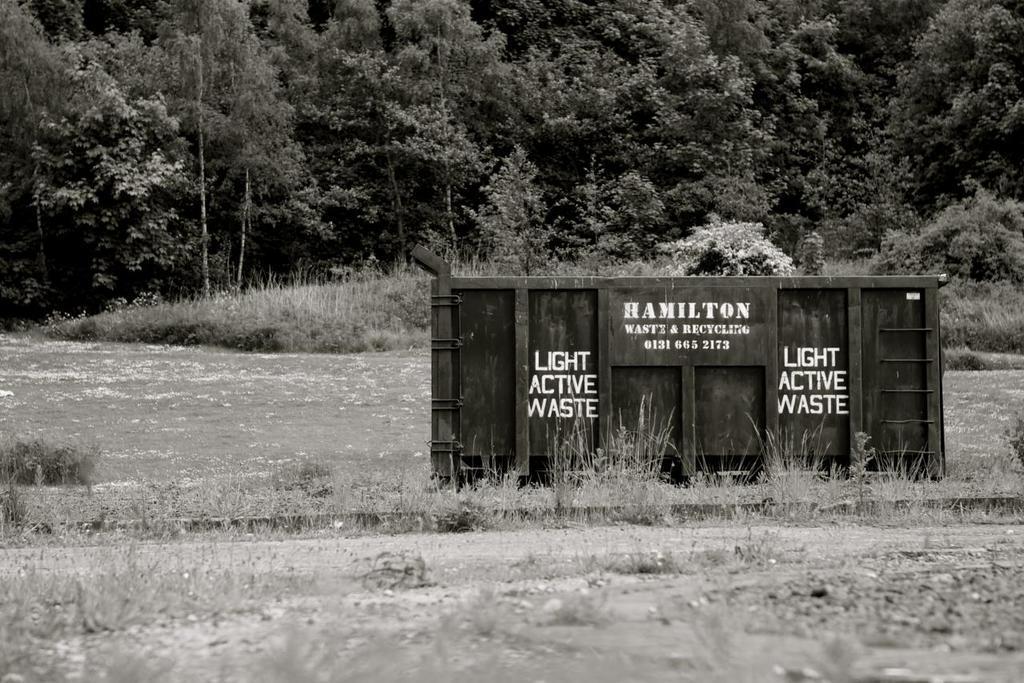Describe this image in one or two sentences. In this image I can see a board and something written on the board, background I can see trees and the image is in black and white. 